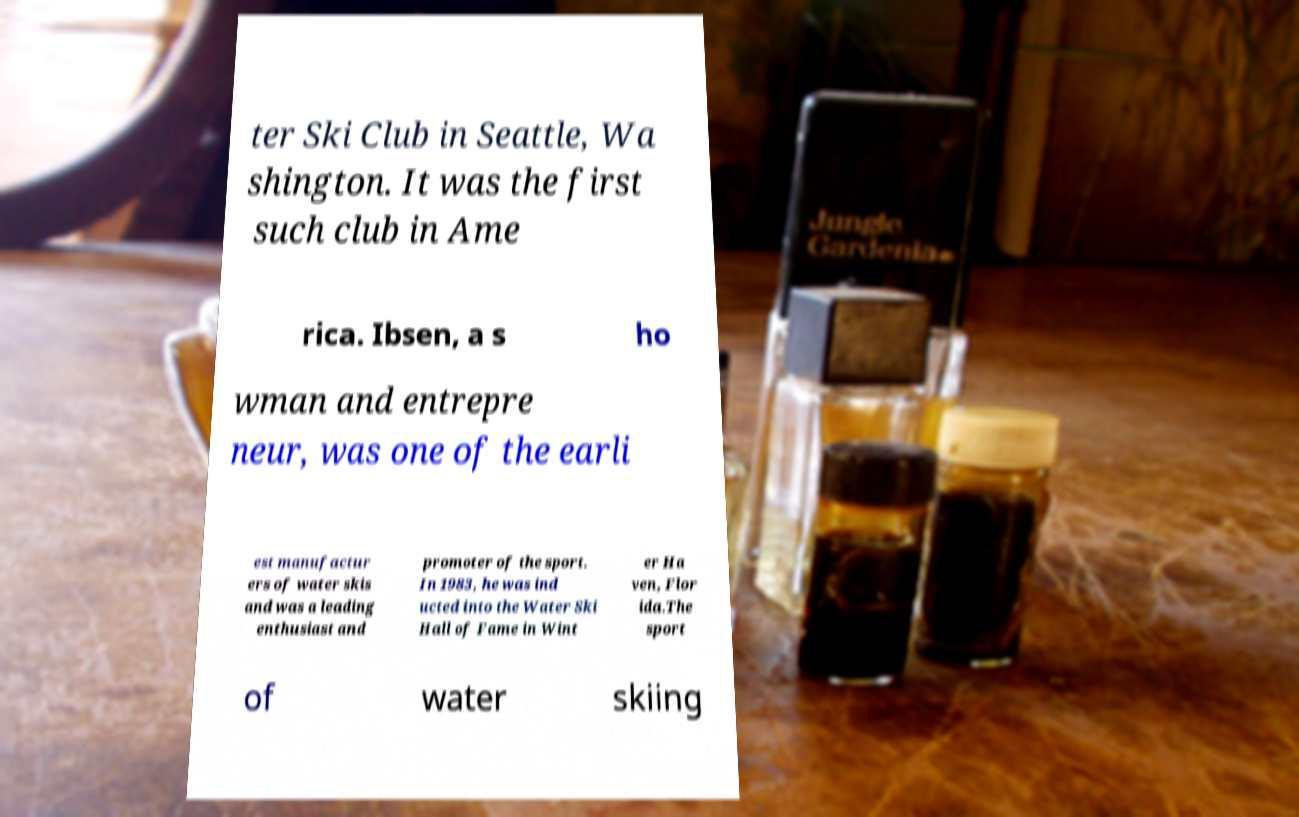For documentation purposes, I need the text within this image transcribed. Could you provide that? ter Ski Club in Seattle, Wa shington. It was the first such club in Ame rica. Ibsen, a s ho wman and entrepre neur, was one of the earli est manufactur ers of water skis and was a leading enthusiast and promoter of the sport. In 1983, he was ind ucted into the Water Ski Hall of Fame in Wint er Ha ven, Flor ida.The sport of water skiing 